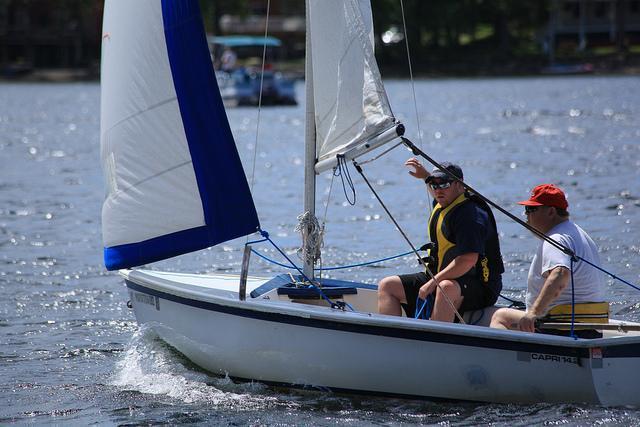How many people are in the boat?
Give a very brief answer. 2. How many boats can be seen?
Give a very brief answer. 2. How many people are there?
Give a very brief answer. 2. 